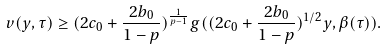<formula> <loc_0><loc_0><loc_500><loc_500>v ( y , \tau ) \geq ( 2 c _ { 0 } + \frac { 2 b _ { 0 } } { 1 - p } ) ^ { \frac { 1 } { p - 1 } } g ( ( 2 c _ { 0 } + \frac { 2 b _ { 0 } } { 1 - p } ) ^ { 1 / 2 } y , \beta ( \tau ) ) .</formula> 